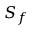Convert formula to latex. <formula><loc_0><loc_0><loc_500><loc_500>S _ { f }</formula> 